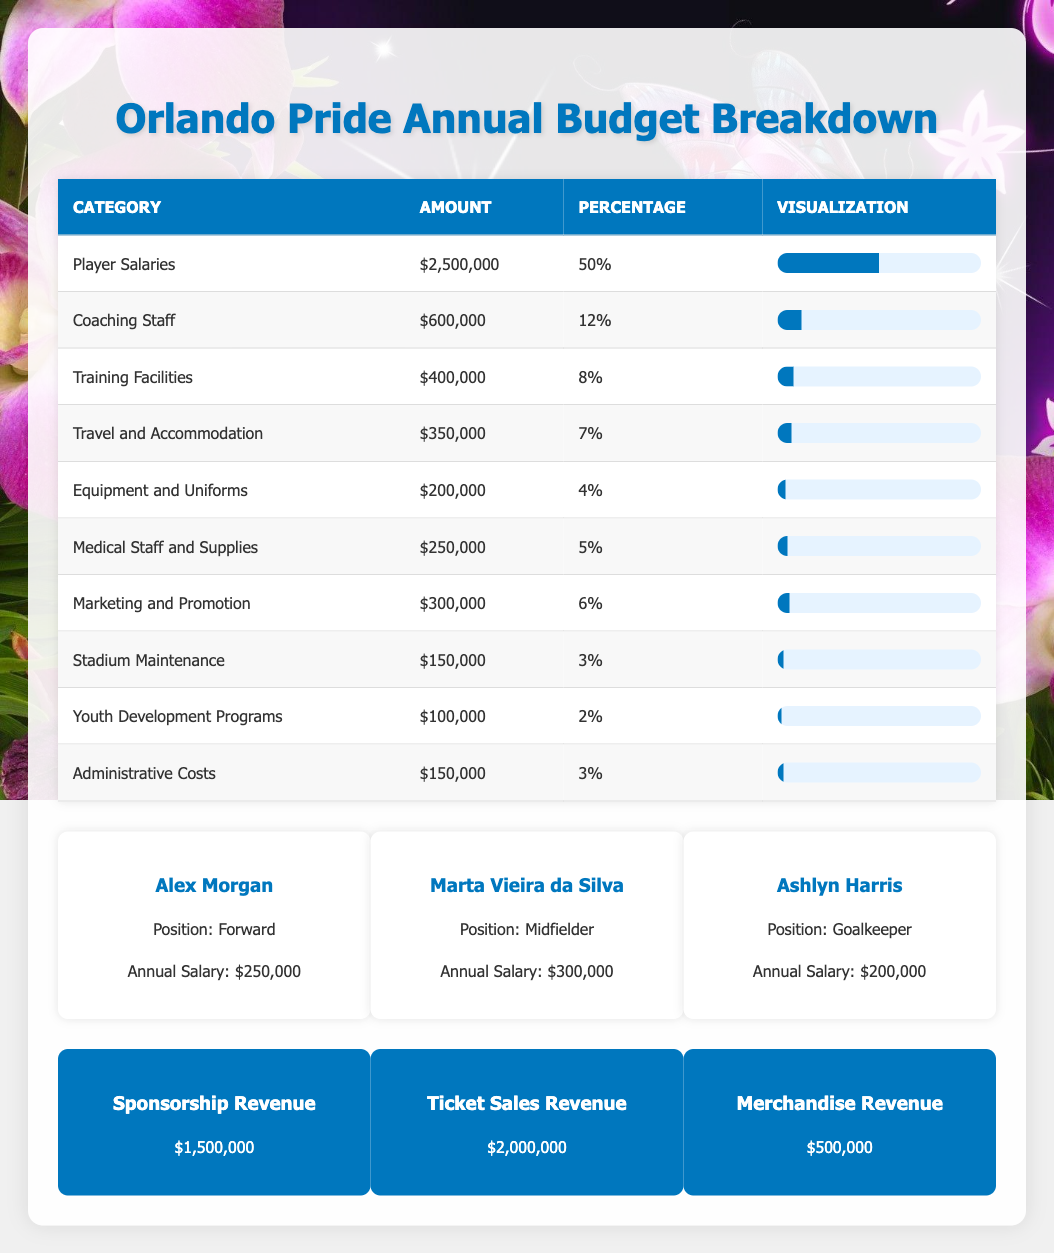What is the total annual budget for the Orlando Pride? The total annual budget for the Orlando Pride is explicitly stated in the data. It is found under the key "total_annual_budget".
Answer: 5000000 What percentage of the budget is allocated to player salaries? The category "Player Salaries" shows that it accounts for 50% of the total budget. This can be directly found in the breakdown.
Answer: 50% Which category receives the least amount of funding? By looking at the "Amount" column, "Youth Development Programs" has the lowest funding of $100,000. This is determined by comparing all amounts listed.
Answer: Youth Development Programs Is the budget for Marketing and Promotion greater than that for Equipment and Uniforms? By comparing the amounts, Marketing and Promotion is $300,000 while Equipment and Uniforms is $200,000. Since $300,000 is greater than $200,000, the answer is yes.
Answer: Yes Calculate the total amount allocated for Coaching Staff and Medical Staff combined. To find this, add the amounts allocated for both Coaching Staff ($600,000) and Medical Staff ($250,000). The sum is $600,000 + $250,000 = $850,000.
Answer: 850000 What is the total revenue generated from ticket sales and sponsorship combined? To find this total, add the ticket sales revenue ($2,000,000) and the sponsorship revenue ($1,500,000). We compute $2,000,000 + $1,500,000 = $3,500,000.
Answer: 3500000 Does the amount spent on Stadium Maintenance exceed that spent on Equipment and Uniforms? The budget for Stadium Maintenance is $150,000, and the amount for Equipment and Uniforms is $200,000. Since $150,000 does not exceed $200,000, the answer is no.
Answer: No Which player has the highest annual salary, and what is that amount? From the list of key players, Marta Vieira da Silva has the highest annual salary of $300,000, which can be directly found in their respective salary data.
Answer: Marta Vieira da Silva, 300000 If we consider all categories of budget breakdown, how much percentage does the total of Travel and Accommodation and Training Facilities occupy? The percentage for Travel and Accommodation is 7%, and for Training Facilities, it is 8%. To find the total, we sum these two percentages: 7% + 8% = 15%.
Answer: 15 